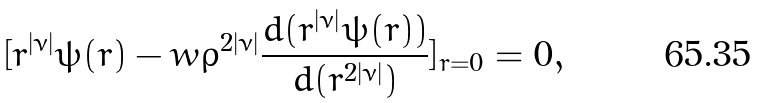Convert formula to latex. <formula><loc_0><loc_0><loc_500><loc_500>[ r ^ { | \nu | } \psi ( r ) - w \rho ^ { 2 | \nu | } \frac { d ( r ^ { | \nu | } \psi ( r ) ) } { d ( r ^ { 2 | \nu | } ) } ] _ { r = 0 } = 0 ,</formula> 